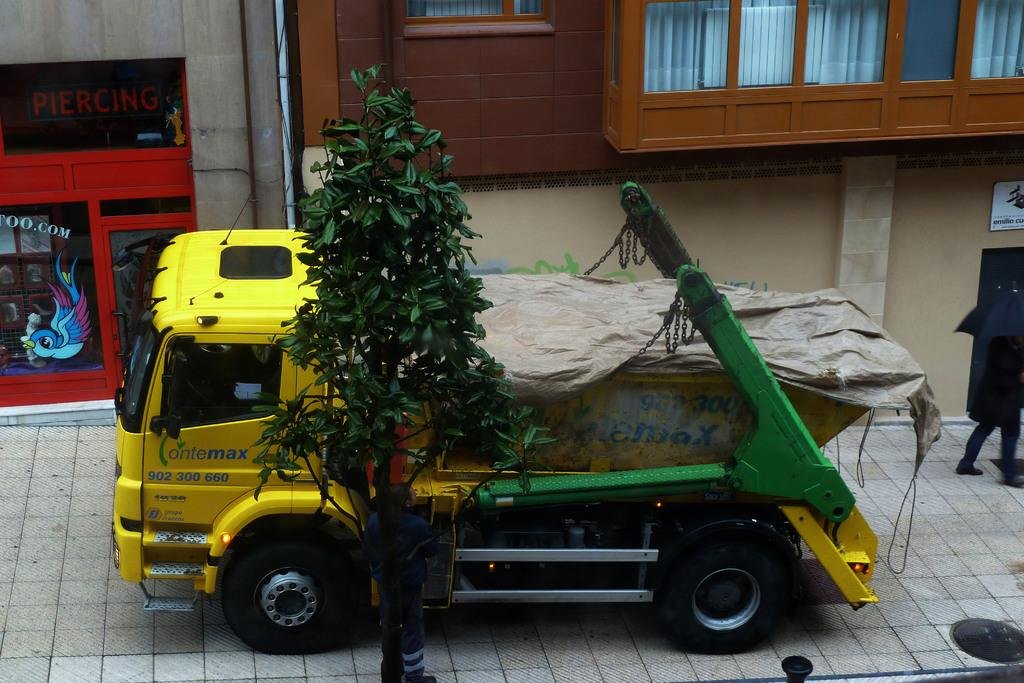What vehicle is on the footpath in the image? There is a truck on the footpath in the image. Can you describe the person in the image? There is a person standing beside a tree in the image. What type of structure is visible in the image? There is a building with windows visible in the image. What type of disease is affecting the tree in the image? There is no indication of a disease affecting the tree in the image; it appears to be a healthy tree. What type of plastic material is visible in the image? There is no plastic material visible in the image. 